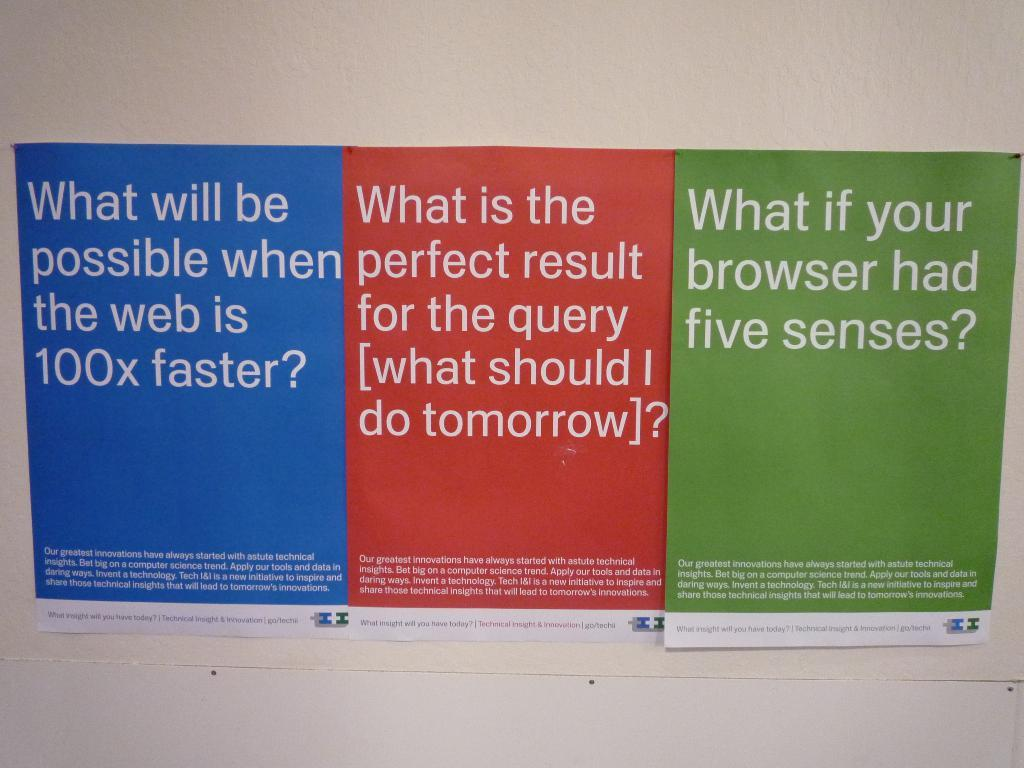<image>
Render a clear and concise summary of the photo. Three signs written side by side and one asking about five senses 